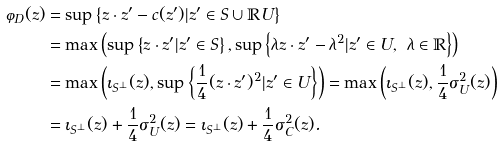<formula> <loc_0><loc_0><loc_500><loc_500>\varphi _ { D } ( z ) & = \sup \left \{ z \cdot z ^ { \prime } - c ( z ^ { \prime } ) | z ^ { \prime } \in S \cup \mathbb { R } U \right \} \\ & = \max \left ( \sup \left \{ z \cdot z ^ { \prime } | z ^ { \prime } \in S \right \} , \sup \left \{ \lambda z \cdot z ^ { \prime } - \lambda ^ { 2 } | z ^ { \prime } \in U , \ \lambda \in \mathbb { R } \right \} \right ) \\ & = \max \left ( \iota _ { S ^ { \perp } } ( z ) , \sup \left \{ \frac { 1 } { 4 } ( z \cdot z ^ { \prime } ) ^ { 2 } | z ^ { \prime } \in U \right \} \right ) = \max \left ( \iota _ { S ^ { \perp } } ( z ) , \frac { 1 } { 4 } \sigma _ { U } ^ { 2 } ( z ) \right ) \\ & = \iota _ { S ^ { \perp } } ( z ) + \frac { 1 } { 4 } \sigma _ { U } ^ { 2 } ( z ) = \iota _ { S ^ { \perp } } ( z ) + \frac { 1 } { 4 } \sigma _ { C } ^ { 2 } ( z ) .</formula> 